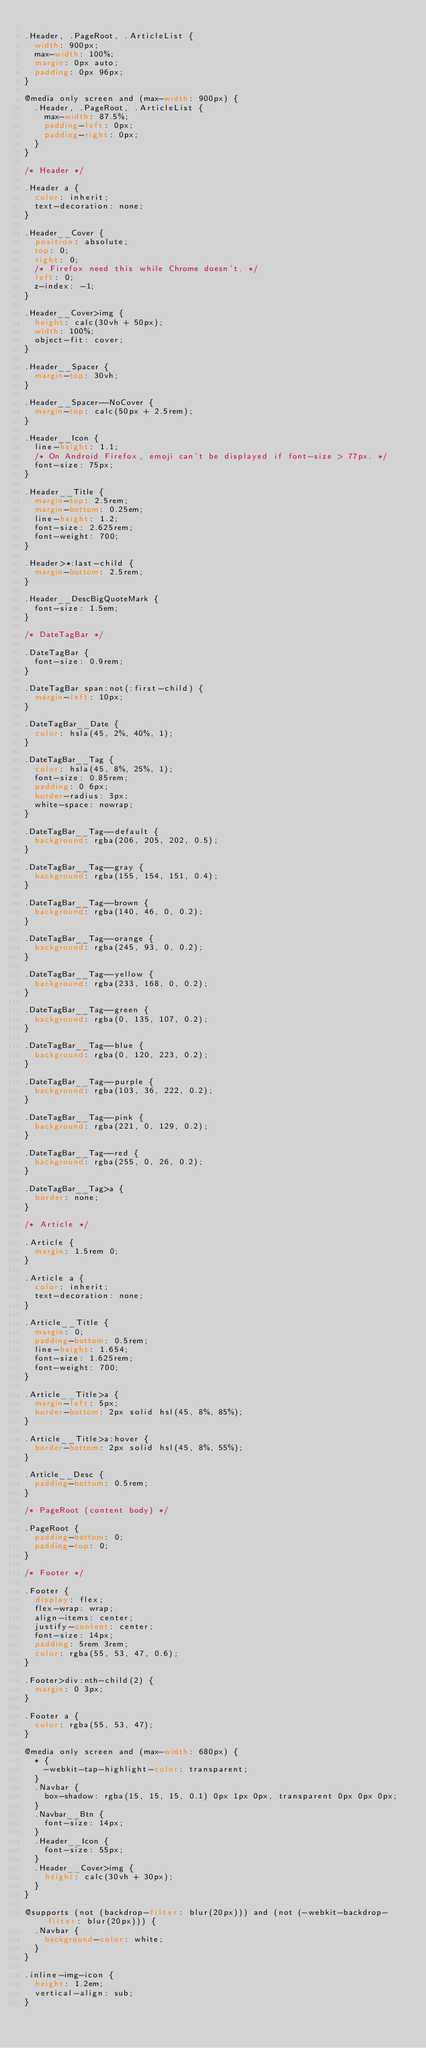<code> <loc_0><loc_0><loc_500><loc_500><_CSS_>
.Header, .PageRoot, .ArticleList {
  width: 900px;
  max-width: 100%;
  margin: 0px auto;
  padding: 0px 96px;
}

@media only screen and (max-width: 900px) {
  .Header, .PageRoot, .ArticleList {
    max-width: 87.5%;
    padding-left: 0px;
    padding-right: 0px;
  }
}

/* Header */

.Header a {
  color: inherit;
  text-decoration: none;
}

.Header__Cover {
  position: absolute;
  top: 0;
  right: 0;
  /* Firefox need this while Chrome doesn't. */
  left: 0;
  z-index: -1;
}

.Header__Cover>img {
  height: calc(30vh + 50px);
  width: 100%;
  object-fit: cover;
}

.Header__Spacer {
  margin-top: 30vh;
}

.Header__Spacer--NoCover {
  margin-top: calc(50px + 2.5rem);
}

.Header__Icon {
  line-height: 1.1;
  /* On Android Firefox, emoji can't be displayed if font-size > 77px. */
  font-size: 75px;
}

.Header__Title {
  margin-top: 2.5rem;
  margin-bottom: 0.25em;
  line-height: 1.2;
  font-size: 2.625rem;
  font-weight: 700;
}

.Header>*:last-child {
  margin-bottom: 2.5rem;
}

.Header__DescBigQuoteMark {
  font-size: 1.5em;
}

/* DateTagBar */

.DateTagBar {
  font-size: 0.9rem;
}

.DateTagBar span:not(:first-child) {
  margin-left: 10px;
}

.DateTagBar__Date {
  color: hsla(45, 2%, 40%, 1);
}

.DateTagBar__Tag {
  color: hsla(45, 8%, 25%, 1);
  font-size: 0.85rem;
  padding: 0 6px;
  border-radius: 3px;
  white-space: nowrap;
}

.DateTagBar__Tag--default {
  background: rgba(206, 205, 202, 0.5);
}

.DateTagBar__Tag--gray {
  background: rgba(155, 154, 151, 0.4);
}

.DateTagBar__Tag--brown {
  background: rgba(140, 46, 0, 0.2);
}

.DateTagBar__Tag--orange {
  background: rgba(245, 93, 0, 0.2);
}

.DateTagBar__Tag--yellow {
  background: rgba(233, 168, 0, 0.2);
}

.DateTagBar__Tag--green {
  background: rgba(0, 135, 107, 0.2);
}

.DateTagBar__Tag--blue {
  background: rgba(0, 120, 223, 0.2);
}

.DateTagBar__Tag--purple {
  background: rgba(103, 36, 222, 0.2);
}

.DateTagBar__Tag--pink {
  background: rgba(221, 0, 129, 0.2);
}

.DateTagBar__Tag--red {
  background: rgba(255, 0, 26, 0.2);
}

.DateTagBar__Tag>a {
  border: none;
}

/* Article */

.Article {
  margin: 1.5rem 0;
}

.Article a {
  color: inherit;
  text-decoration: none;
}

.Article__Title {
  margin: 0;
  padding-bottom: 0.5rem;
  line-height: 1.654;
  font-size: 1.625rem;
  font-weight: 700;
}

.Article__Title>a {
  margin-left: 5px;
  border-bottom: 2px solid hsl(45, 8%, 85%);
}

.Article__Title>a:hover {
  border-bottom: 2px solid hsl(45, 8%, 55%);
}

.Article__Desc {
  padding-bottom: 0.5rem;
}

/* PageRoot (content body) */

.PageRoot {
  padding-bottom: 0;
  padding-top: 0;
}

/* Footer */

.Footer {
  display: flex;
  flex-wrap: wrap;
  align-items: center;
  justify-content: center;
  font-size: 14px;
  padding: 5rem 3rem;
  color: rgba(55, 53, 47, 0.6);
}

.Footer>div:nth-child(2) {
  margin: 0 3px;
}

.Footer a {
  color: rgba(55, 53, 47);
}

@media only screen and (max-width: 680px) {
  * {
    -webkit-tap-highlight-color: transparent;
  }
  .Navbar {
    box-shadow: rgba(15, 15, 15, 0.1) 0px 1px 0px, transparent 0px 0px 0px;
  }
  .Navbar__Btn {
    font-size: 14px;
  }
  .Header__Icon {
    font-size: 55px;
  }
  .Header__Cover>img {
    height: calc(30vh + 30px);
  }
}

@supports (not (backdrop-filter: blur(20px))) and (not (-webkit-backdrop-filter: blur(20px))) {
  .Navbar {
    background-color: white;
  }
}

.inline-img-icon {
  height: 1.2em;
  vertical-align: sub;
}</code> 